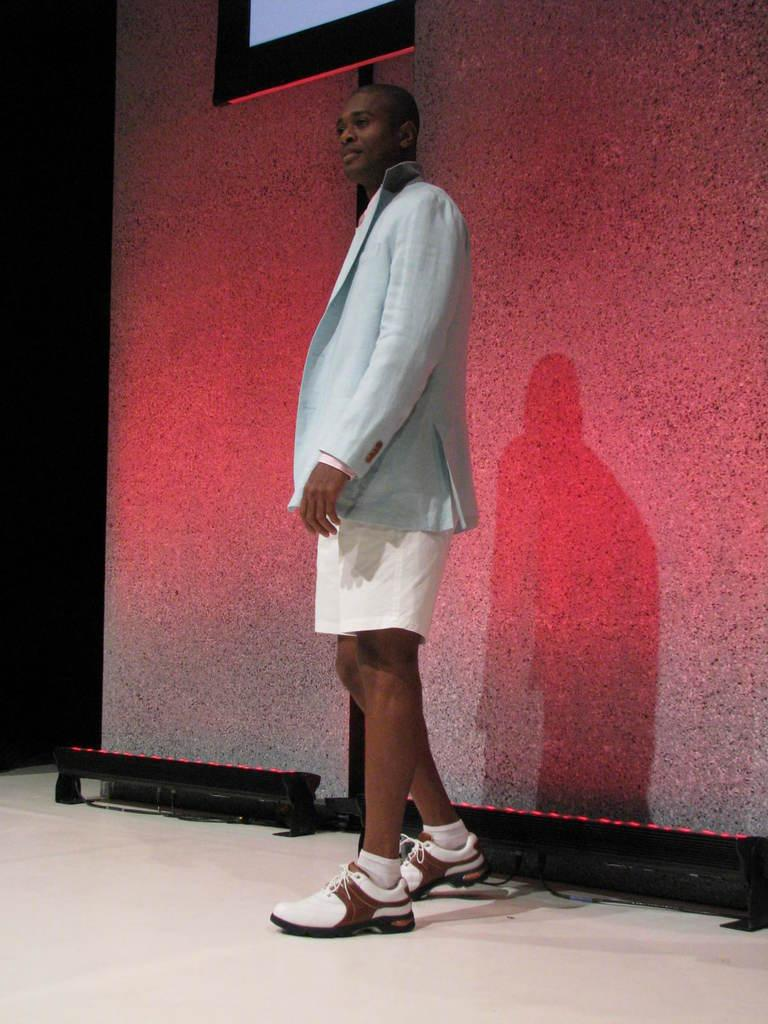What is the main subject of the image? There is a person standing in the image. Where is the person standing? The person is standing on the floor. What can be seen in the background of the image? There is a wall and a screen in the background of the image. What type of cabbage is the person holding in the image? There is no cabbage present in the image; the person is not holding any object. What thoughts can be read on the person's face in the image? The image does not provide any information about the person's thoughts or emotions, so it cannot be determined from the image. 